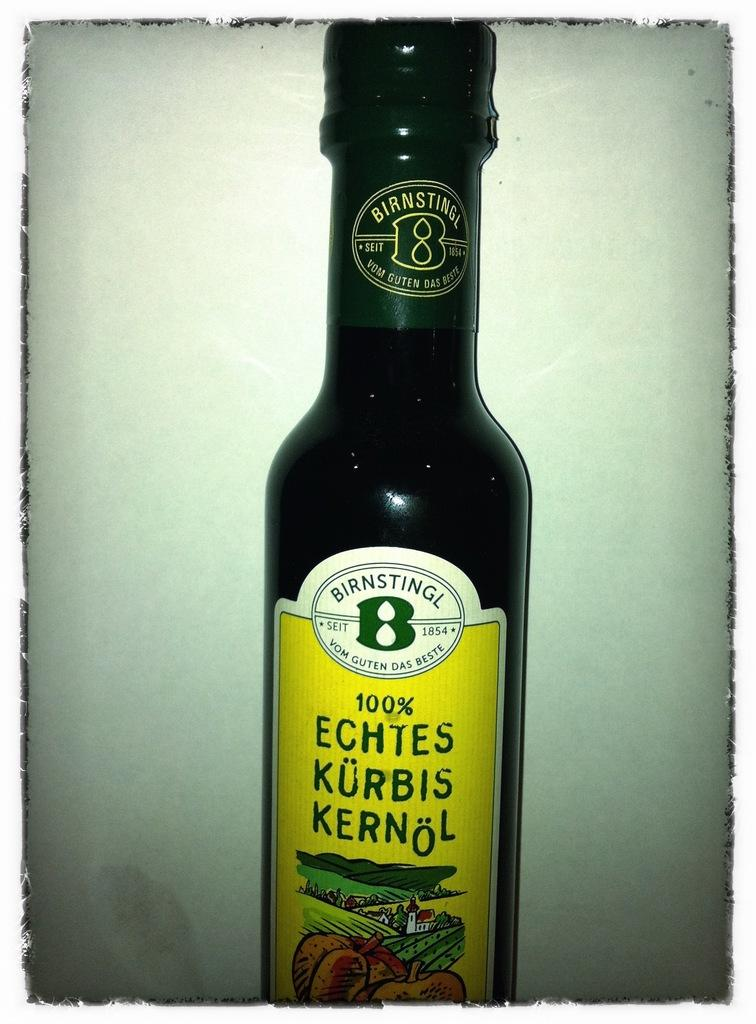Provide a one-sentence caption for the provided image. Green bottle with a yellow label that says 100% on it. 